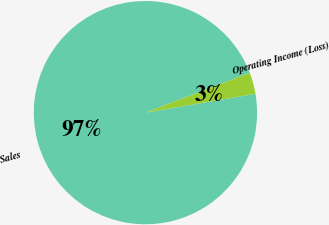Convert chart to OTSL. <chart><loc_0><loc_0><loc_500><loc_500><pie_chart><fcel>Sales<fcel>Operating Income (Loss)<nl><fcel>96.89%<fcel>3.11%<nl></chart> 